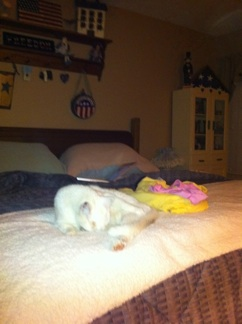Imagine your wildest imagination: What is this cat's secret mission? In a world where cats are secret agents, your feline friend is undercover on a deep-sea mission, disguised as an ordinary house pet. Right now, it's pretending to sleep on the bed while transmitting information back to its underwater base about the mysterious, colorful toy next to it, which is actually a device for decoding whale songs. 